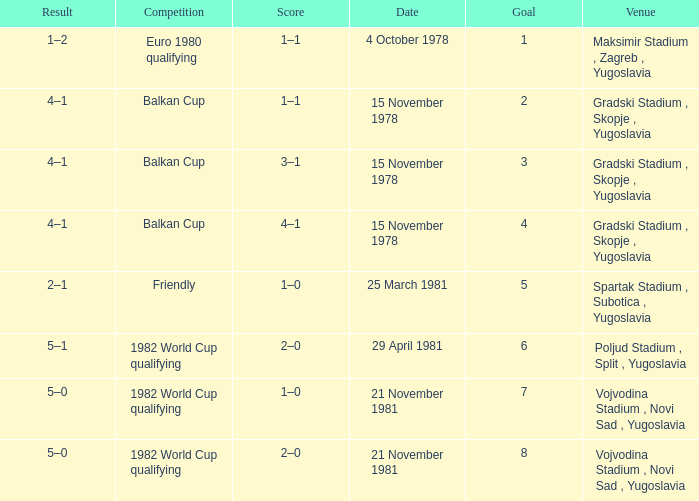What is the Result for Goal 3? 4–1. 